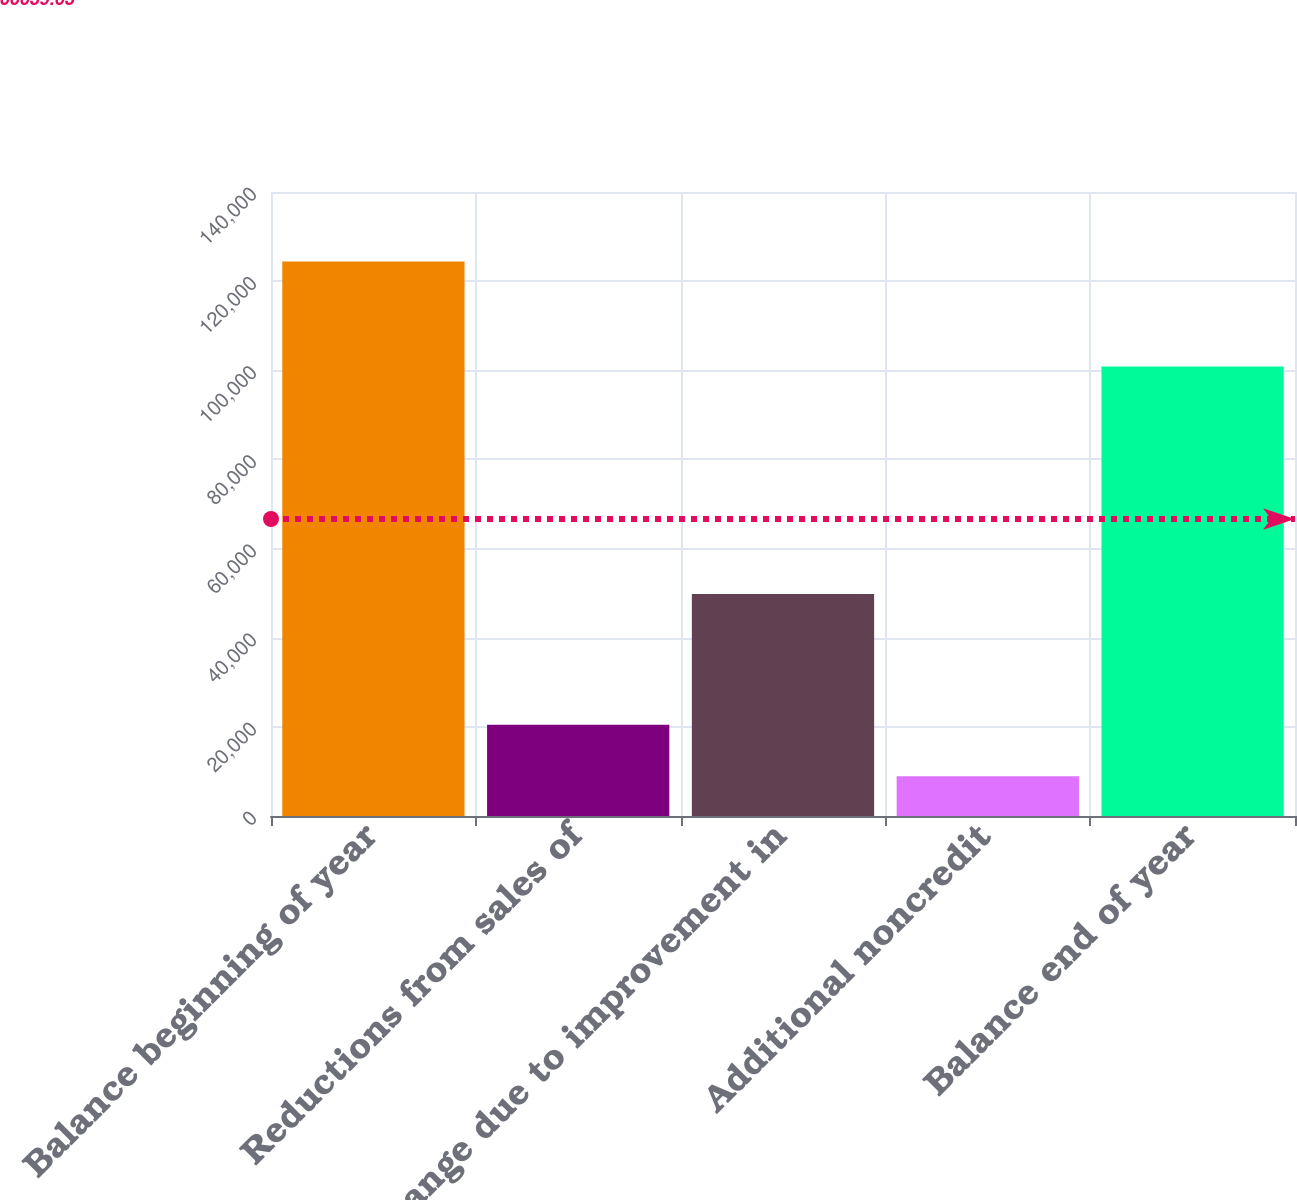<chart> <loc_0><loc_0><loc_500><loc_500><bar_chart><fcel>Balance beginning of year<fcel>Reductions from sales of<fcel>Change due to improvement in<fcel>Additional noncredit<fcel>Balance end of year<nl><fcel>124408<fcel>20472.4<fcel>49802<fcel>8924<fcel>100838<nl></chart> 